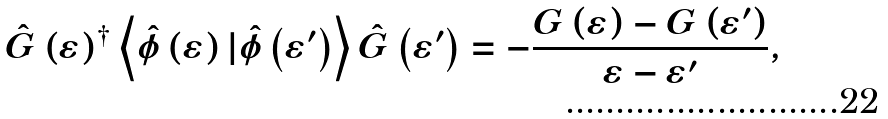Convert formula to latex. <formula><loc_0><loc_0><loc_500><loc_500>\hat { G } \left ( \varepsilon \right ) ^ { \dagger } \left \langle \hat { \phi } \left ( \varepsilon \right ) | \hat { \phi } \left ( \varepsilon ^ { \prime } \right ) \right \rangle \hat { G } \left ( \varepsilon ^ { \prime } \right ) = - \frac { G \left ( \varepsilon \right ) - G \left ( \varepsilon ^ { \prime } \right ) } { \varepsilon - \varepsilon ^ { \prime } } ,</formula> 